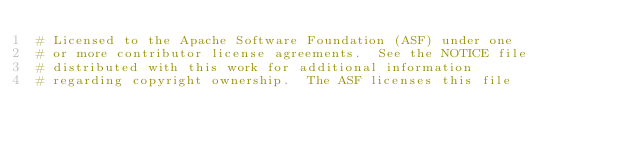<code> <loc_0><loc_0><loc_500><loc_500><_Python_># Licensed to the Apache Software Foundation (ASF) under one
# or more contributor license agreements.  See the NOTICE file
# distributed with this work for additional information
# regarding copyright ownership.  The ASF licenses this file</code> 